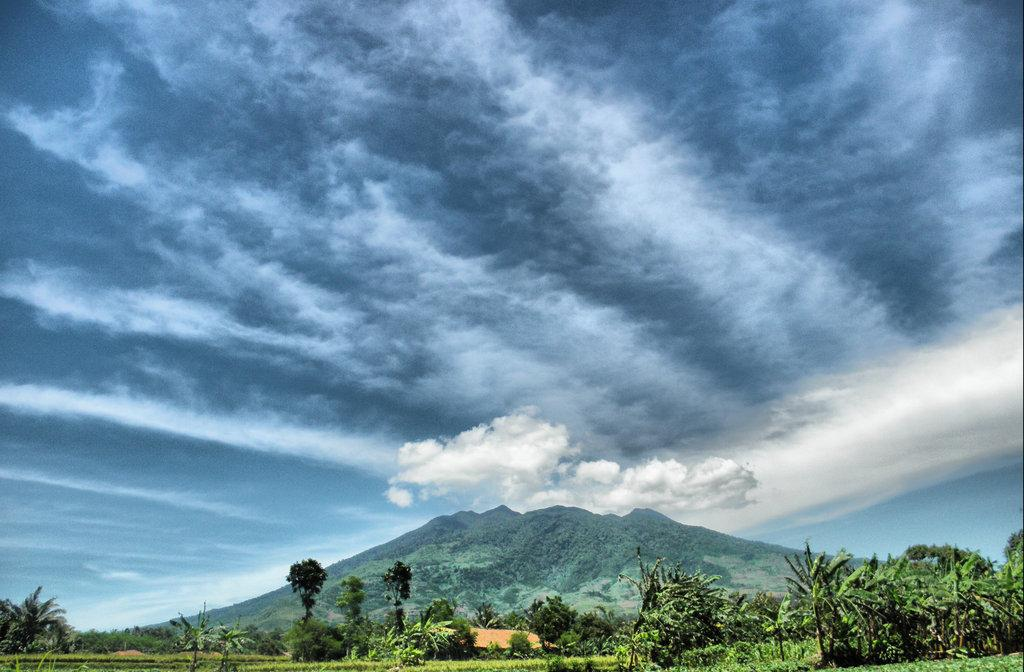What type of vegetation is present in the image? There are green trees in the image. What geographical feature can be seen in the background of the image? The image appears to depict a hill in the background. What is the condition of the sky in the image? The sky is cloudy at the top of the image. Can you see an owl perched on one of the trees in the image? There is no owl present in the image; it only features green trees and a hill in the background. 